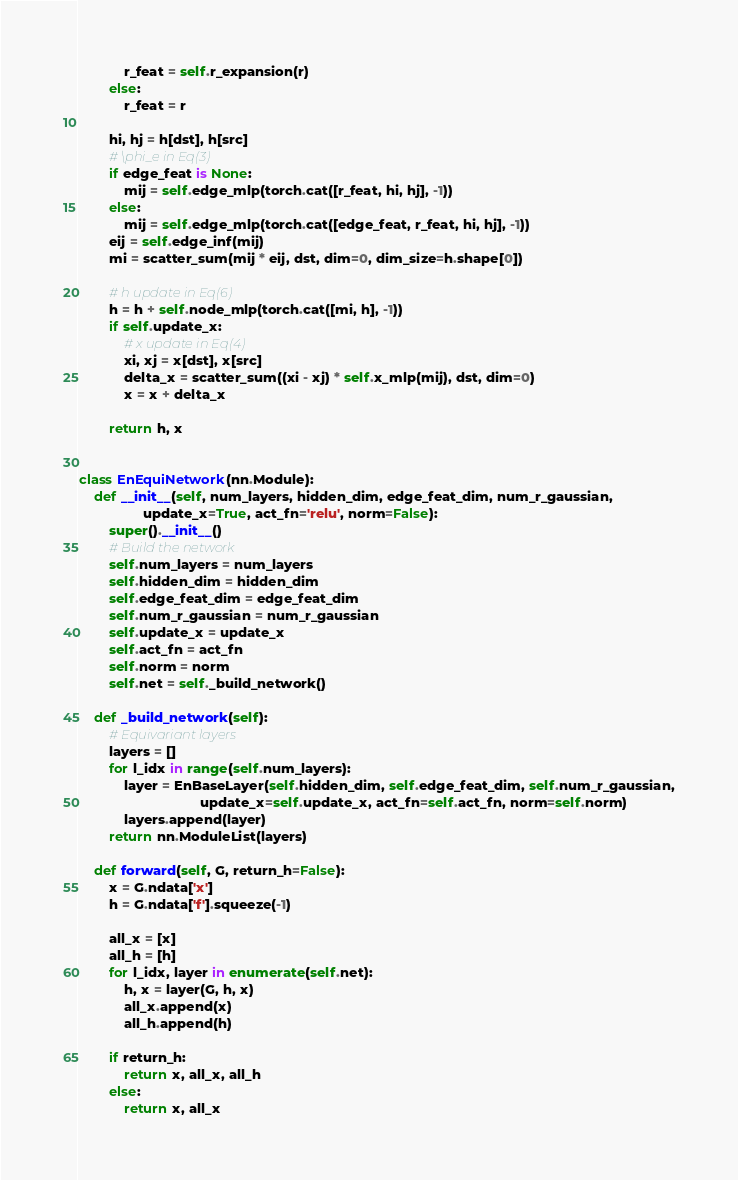<code> <loc_0><loc_0><loc_500><loc_500><_Python_>            r_feat = self.r_expansion(r)
        else:
            r_feat = r

        hi, hj = h[dst], h[src]
        # \phi_e in Eq(3)
        if edge_feat is None:
            mij = self.edge_mlp(torch.cat([r_feat, hi, hj], -1))
        else:
            mij = self.edge_mlp(torch.cat([edge_feat, r_feat, hi, hj], -1))
        eij = self.edge_inf(mij)
        mi = scatter_sum(mij * eij, dst, dim=0, dim_size=h.shape[0])

        # h update in Eq(6)
        h = h + self.node_mlp(torch.cat([mi, h], -1))
        if self.update_x:
            # x update in Eq(4)
            xi, xj = x[dst], x[src]
            delta_x = scatter_sum((xi - xj) * self.x_mlp(mij), dst, dim=0)
            x = x + delta_x

        return h, x


class EnEquiNetwork(nn.Module):
    def __init__(self, num_layers, hidden_dim, edge_feat_dim, num_r_gaussian,
                 update_x=True, act_fn='relu', norm=False):
        super().__init__()
        # Build the network
        self.num_layers = num_layers
        self.hidden_dim = hidden_dim
        self.edge_feat_dim = edge_feat_dim
        self.num_r_gaussian = num_r_gaussian
        self.update_x = update_x
        self.act_fn = act_fn
        self.norm = norm
        self.net = self._build_network()

    def _build_network(self):
        # Equivariant layers
        layers = []
        for l_idx in range(self.num_layers):
            layer = EnBaseLayer(self.hidden_dim, self.edge_feat_dim, self.num_r_gaussian,
                                update_x=self.update_x, act_fn=self.act_fn, norm=self.norm)
            layers.append(layer)
        return nn.ModuleList(layers)

    def forward(self, G, return_h=False):
        x = G.ndata['x']
        h = G.ndata['f'].squeeze(-1)

        all_x = [x]
        all_h = [h]
        for l_idx, layer in enumerate(self.net):
            h, x = layer(G, h, x)
            all_x.append(x)
            all_h.append(h)

        if return_h:
            return x, all_x, all_h
        else:
            return x, all_x
</code> 